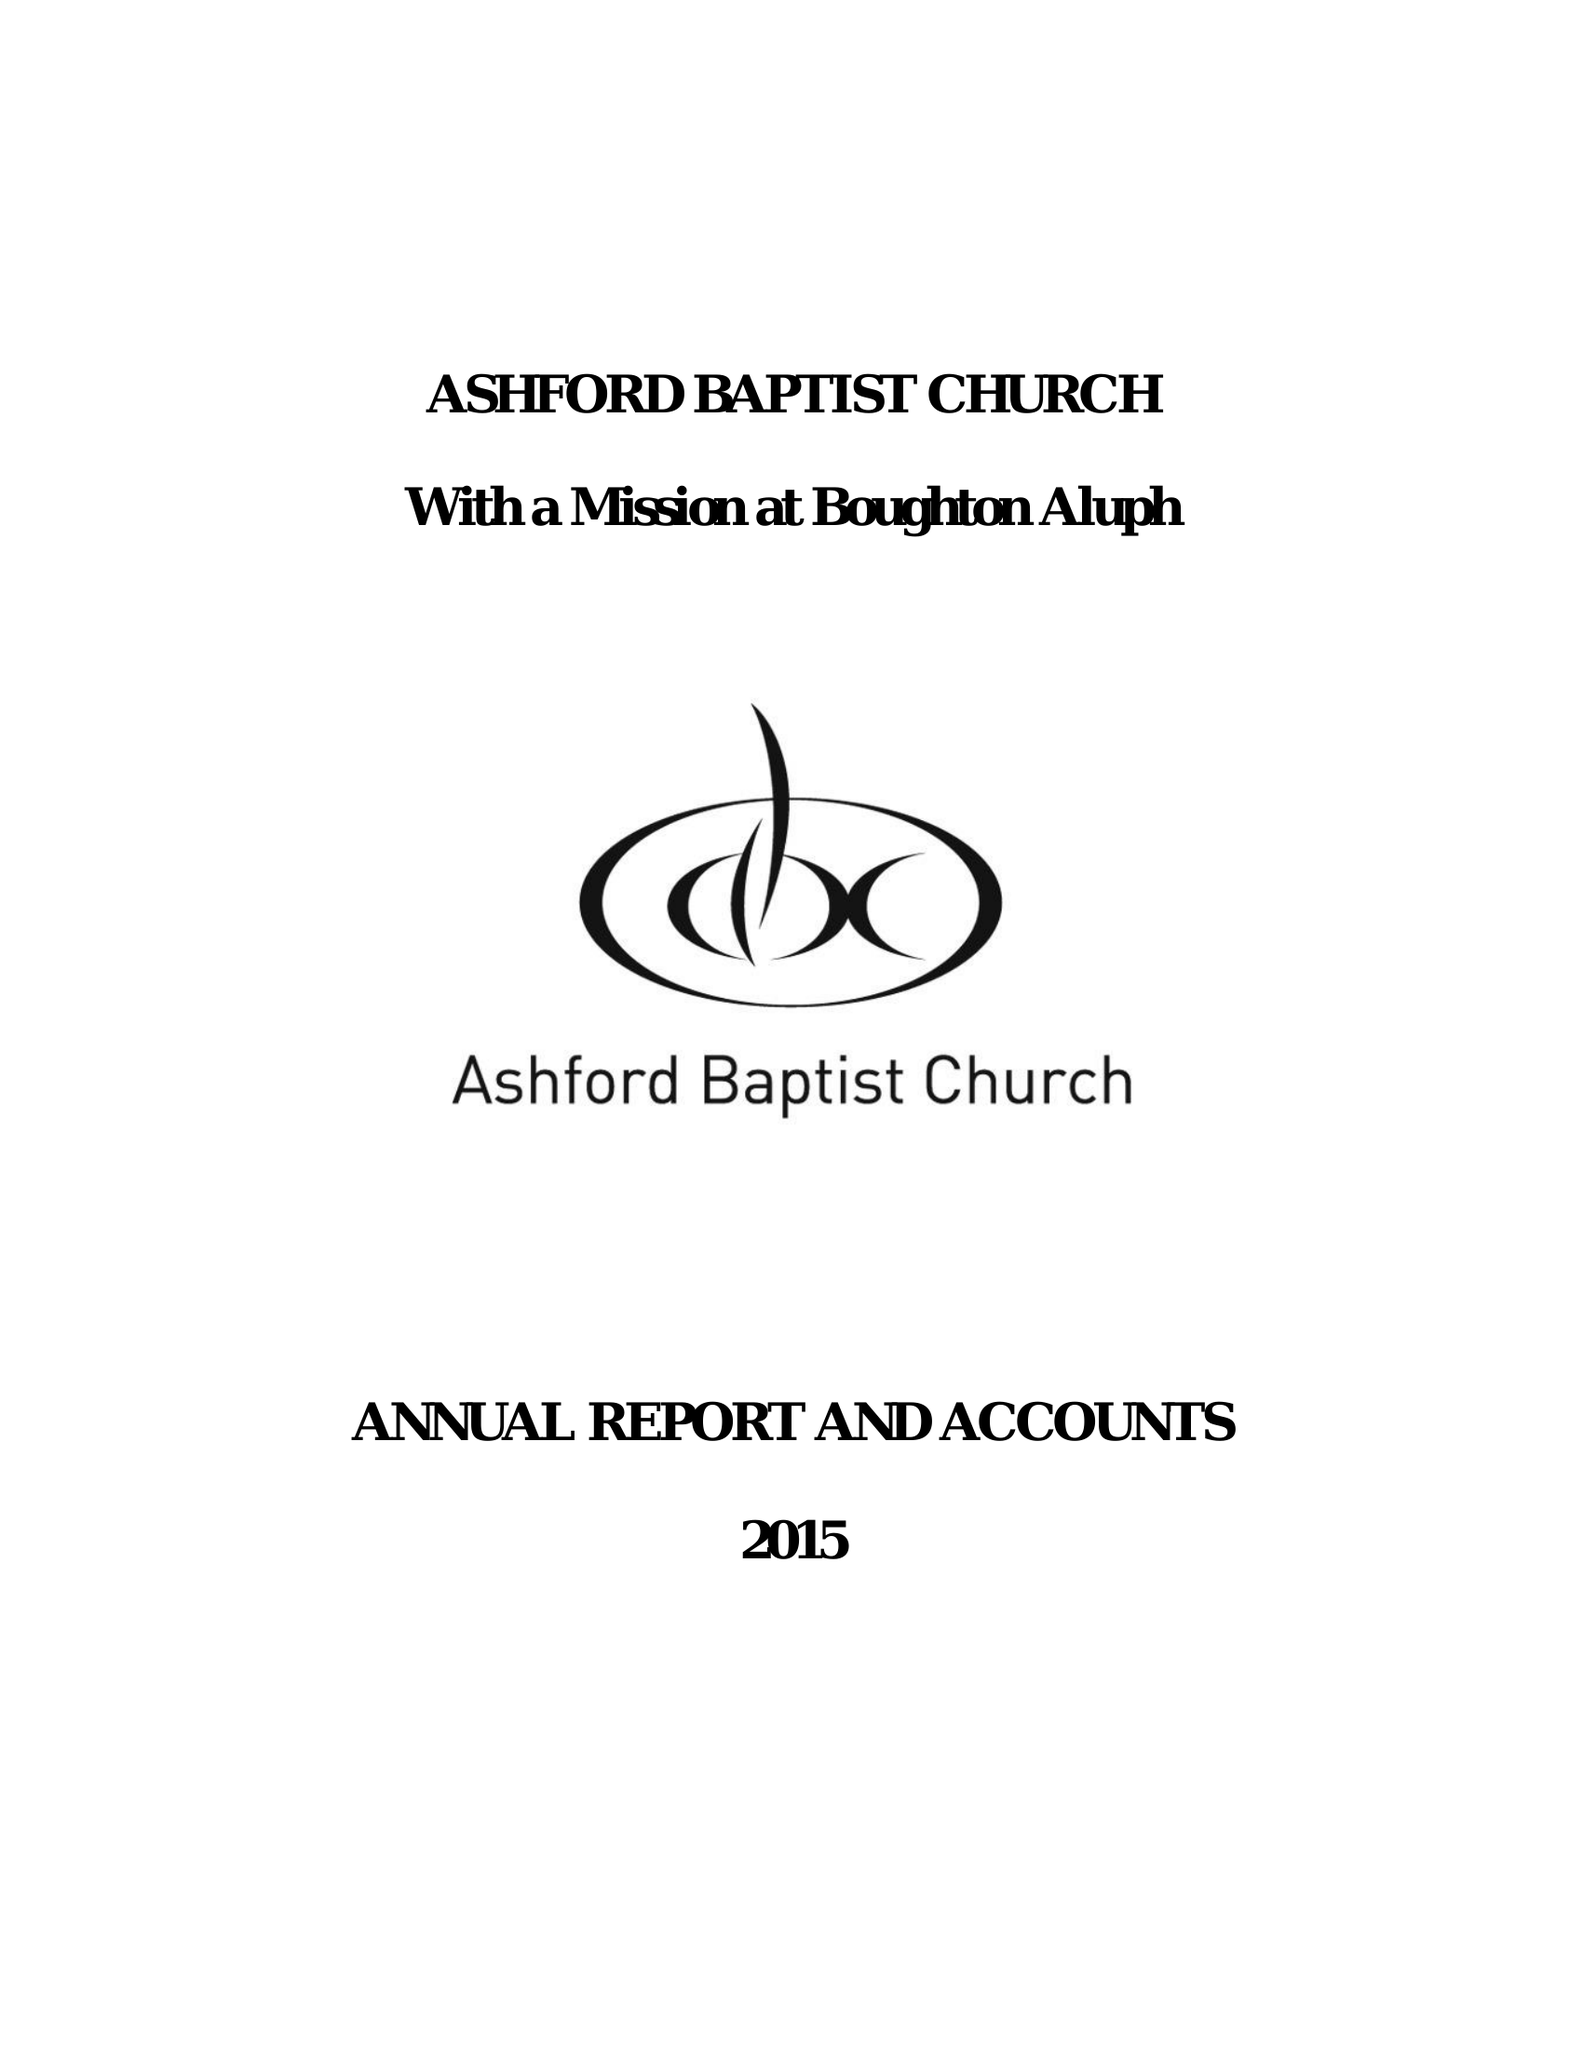What is the value for the address__street_line?
Answer the question using a single word or phrase. ST. JOHNS LANE 